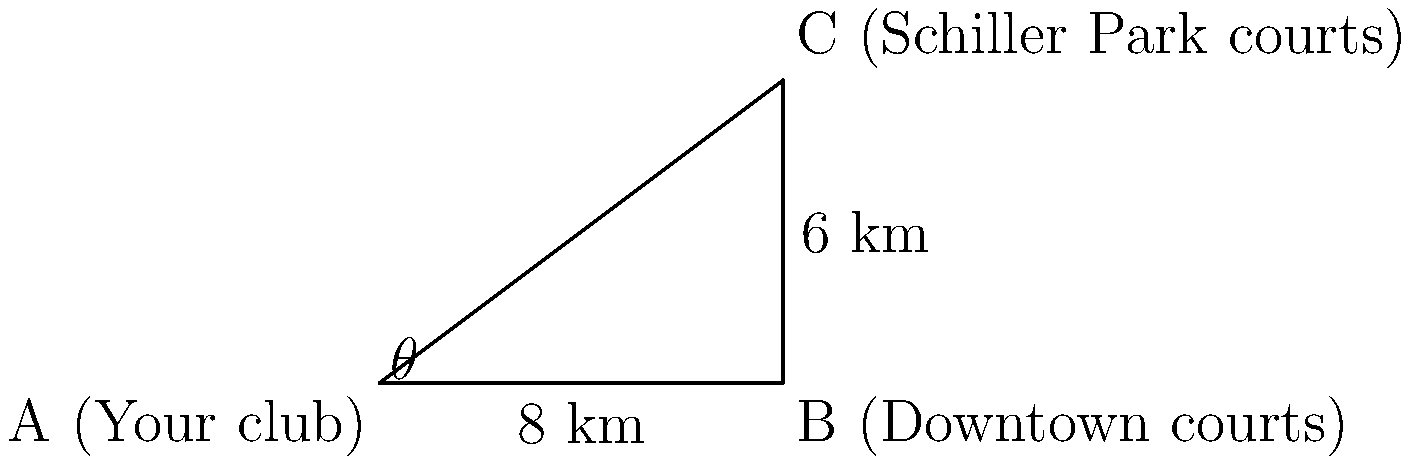You're planning a tennis tournament in Columbus and need to calculate the distance between your local club (point A) and the courts at Schiller Park (point C). You know that the downtown courts (point B) are 8 km east of your club and the Schiller Park courts are 6 km north of the downtown courts. Using trigonometric ratios, calculate the direct distance between your club and the Schiller Park courts to the nearest tenth of a kilometer. Let's approach this step-by-step:

1) The given information forms a right triangle, where:
   - The base (AB) is 8 km
   - The height (BC) is 6 km
   - We need to find the hypotenuse (AC)

2) We can use the Pythagorean theorem to solve this:
   $AC^2 = AB^2 + BC^2$

3) Substituting the values:
   $AC^2 = 8^2 + 6^2$

4) Simplify:
   $AC^2 = 64 + 36 = 100$

5) Take the square root of both sides:
   $AC = \sqrt{100} = 10$

6) Therefore, the distance between your club and the Schiller Park courts is 10 km.

As a bonus, we can also calculate the angle $\theta$:
$\tan(\theta) = \frac{opposite}{adjacent} = \frac{6}{8} = 0.75$
$\theta = \arctan(0.75) \approx 36.9°$

This means you'd need to travel at an angle of approximately 36.9° northeast from your club to reach Schiller Park courts directly.
Answer: 10 km 